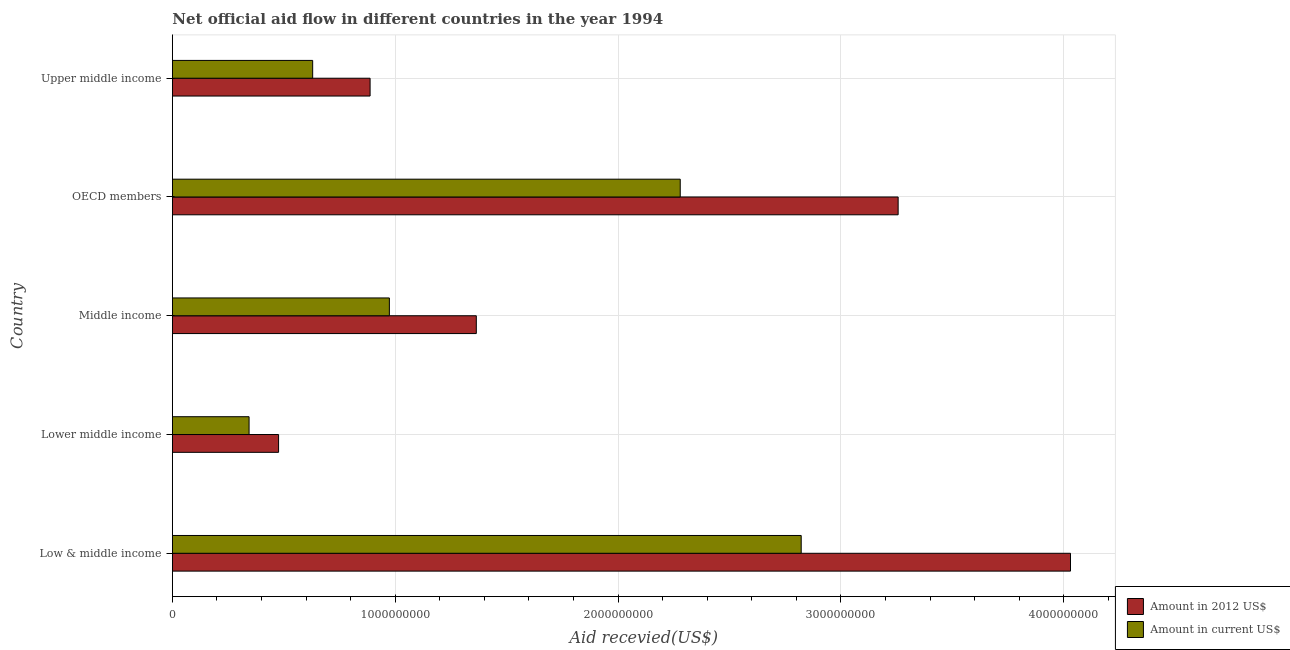How many groups of bars are there?
Your answer should be very brief. 5. Are the number of bars on each tick of the Y-axis equal?
Provide a short and direct response. Yes. What is the label of the 5th group of bars from the top?
Your answer should be very brief. Low & middle income. What is the amount of aid received(expressed in 2012 us$) in Lower middle income?
Make the answer very short. 4.77e+08. Across all countries, what is the maximum amount of aid received(expressed in us$)?
Give a very brief answer. 2.82e+09. Across all countries, what is the minimum amount of aid received(expressed in us$)?
Your response must be concise. 3.44e+08. In which country was the amount of aid received(expressed in 2012 us$) minimum?
Your answer should be compact. Lower middle income. What is the total amount of aid received(expressed in us$) in the graph?
Your answer should be very brief. 7.05e+09. What is the difference between the amount of aid received(expressed in 2012 us$) in Middle income and that in Upper middle income?
Ensure brevity in your answer.  4.77e+08. What is the difference between the amount of aid received(expressed in us$) in Low & middle income and the amount of aid received(expressed in 2012 us$) in OECD members?
Make the answer very short. -4.35e+08. What is the average amount of aid received(expressed in us$) per country?
Provide a succinct answer. 1.41e+09. What is the difference between the amount of aid received(expressed in us$) and amount of aid received(expressed in 2012 us$) in OECD members?
Provide a short and direct response. -9.78e+08. In how many countries, is the amount of aid received(expressed in us$) greater than 2600000000 US$?
Offer a terse response. 1. What is the ratio of the amount of aid received(expressed in us$) in Low & middle income to that in Upper middle income?
Offer a terse response. 4.48. Is the amount of aid received(expressed in 2012 us$) in Low & middle income less than that in Middle income?
Provide a succinct answer. No. Is the difference between the amount of aid received(expressed in 2012 us$) in Lower middle income and Upper middle income greater than the difference between the amount of aid received(expressed in us$) in Lower middle income and Upper middle income?
Your answer should be compact. No. What is the difference between the highest and the second highest amount of aid received(expressed in 2012 us$)?
Give a very brief answer. 7.73e+08. What is the difference between the highest and the lowest amount of aid received(expressed in us$)?
Provide a succinct answer. 2.48e+09. In how many countries, is the amount of aid received(expressed in 2012 us$) greater than the average amount of aid received(expressed in 2012 us$) taken over all countries?
Provide a short and direct response. 2. What does the 1st bar from the top in Low & middle income represents?
Your answer should be very brief. Amount in current US$. What does the 2nd bar from the bottom in Upper middle income represents?
Your answer should be very brief. Amount in current US$. How many bars are there?
Make the answer very short. 10. How many countries are there in the graph?
Your answer should be very brief. 5. Are the values on the major ticks of X-axis written in scientific E-notation?
Offer a terse response. No. Does the graph contain any zero values?
Offer a very short reply. No. Where does the legend appear in the graph?
Your answer should be compact. Bottom right. How many legend labels are there?
Keep it short and to the point. 2. What is the title of the graph?
Give a very brief answer. Net official aid flow in different countries in the year 1994. Does "Females" appear as one of the legend labels in the graph?
Your answer should be very brief. No. What is the label or title of the X-axis?
Your answer should be compact. Aid recevied(US$). What is the Aid recevied(US$) of Amount in 2012 US$ in Low & middle income?
Your answer should be very brief. 4.03e+09. What is the Aid recevied(US$) of Amount in current US$ in Low & middle income?
Your answer should be very brief. 2.82e+09. What is the Aid recevied(US$) in Amount in 2012 US$ in Lower middle income?
Offer a very short reply. 4.77e+08. What is the Aid recevied(US$) in Amount in current US$ in Lower middle income?
Keep it short and to the point. 3.44e+08. What is the Aid recevied(US$) in Amount in 2012 US$ in Middle income?
Ensure brevity in your answer.  1.36e+09. What is the Aid recevied(US$) of Amount in current US$ in Middle income?
Give a very brief answer. 9.74e+08. What is the Aid recevied(US$) in Amount in 2012 US$ in OECD members?
Your answer should be compact. 3.26e+09. What is the Aid recevied(US$) of Amount in current US$ in OECD members?
Ensure brevity in your answer.  2.28e+09. What is the Aid recevied(US$) of Amount in 2012 US$ in Upper middle income?
Your answer should be very brief. 8.87e+08. What is the Aid recevied(US$) of Amount in current US$ in Upper middle income?
Ensure brevity in your answer.  6.30e+08. Across all countries, what is the maximum Aid recevied(US$) of Amount in 2012 US$?
Offer a very short reply. 4.03e+09. Across all countries, what is the maximum Aid recevied(US$) in Amount in current US$?
Offer a terse response. 2.82e+09. Across all countries, what is the minimum Aid recevied(US$) of Amount in 2012 US$?
Offer a very short reply. 4.77e+08. Across all countries, what is the minimum Aid recevied(US$) of Amount in current US$?
Ensure brevity in your answer.  3.44e+08. What is the total Aid recevied(US$) in Amount in 2012 US$ in the graph?
Provide a short and direct response. 1.00e+1. What is the total Aid recevied(US$) in Amount in current US$ in the graph?
Keep it short and to the point. 7.05e+09. What is the difference between the Aid recevied(US$) of Amount in 2012 US$ in Low & middle income and that in Lower middle income?
Your response must be concise. 3.55e+09. What is the difference between the Aid recevied(US$) in Amount in current US$ in Low & middle income and that in Lower middle income?
Give a very brief answer. 2.48e+09. What is the difference between the Aid recevied(US$) in Amount in 2012 US$ in Low & middle income and that in Middle income?
Provide a succinct answer. 2.67e+09. What is the difference between the Aid recevied(US$) in Amount in current US$ in Low & middle income and that in Middle income?
Offer a very short reply. 1.85e+09. What is the difference between the Aid recevied(US$) in Amount in 2012 US$ in Low & middle income and that in OECD members?
Your answer should be very brief. 7.73e+08. What is the difference between the Aid recevied(US$) in Amount in current US$ in Low & middle income and that in OECD members?
Provide a short and direct response. 5.43e+08. What is the difference between the Aid recevied(US$) of Amount in 2012 US$ in Low & middle income and that in Upper middle income?
Give a very brief answer. 3.14e+09. What is the difference between the Aid recevied(US$) in Amount in current US$ in Low & middle income and that in Upper middle income?
Give a very brief answer. 2.19e+09. What is the difference between the Aid recevied(US$) of Amount in 2012 US$ in Lower middle income and that in Middle income?
Your answer should be compact. -8.87e+08. What is the difference between the Aid recevied(US$) of Amount in current US$ in Lower middle income and that in Middle income?
Offer a very short reply. -6.30e+08. What is the difference between the Aid recevied(US$) of Amount in 2012 US$ in Lower middle income and that in OECD members?
Your answer should be very brief. -2.78e+09. What is the difference between the Aid recevied(US$) of Amount in current US$ in Lower middle income and that in OECD members?
Keep it short and to the point. -1.93e+09. What is the difference between the Aid recevied(US$) in Amount in 2012 US$ in Lower middle income and that in Upper middle income?
Make the answer very short. -4.11e+08. What is the difference between the Aid recevied(US$) of Amount in current US$ in Lower middle income and that in Upper middle income?
Your answer should be compact. -2.85e+08. What is the difference between the Aid recevied(US$) in Amount in 2012 US$ in Middle income and that in OECD members?
Offer a terse response. -1.89e+09. What is the difference between the Aid recevied(US$) in Amount in current US$ in Middle income and that in OECD members?
Your response must be concise. -1.31e+09. What is the difference between the Aid recevied(US$) of Amount in 2012 US$ in Middle income and that in Upper middle income?
Make the answer very short. 4.77e+08. What is the difference between the Aid recevied(US$) in Amount in current US$ in Middle income and that in Upper middle income?
Provide a short and direct response. 3.44e+08. What is the difference between the Aid recevied(US$) of Amount in 2012 US$ in OECD members and that in Upper middle income?
Offer a terse response. 2.37e+09. What is the difference between the Aid recevied(US$) in Amount in current US$ in OECD members and that in Upper middle income?
Give a very brief answer. 1.65e+09. What is the difference between the Aid recevied(US$) in Amount in 2012 US$ in Low & middle income and the Aid recevied(US$) in Amount in current US$ in Lower middle income?
Provide a short and direct response. 3.69e+09. What is the difference between the Aid recevied(US$) in Amount in 2012 US$ in Low & middle income and the Aid recevied(US$) in Amount in current US$ in Middle income?
Your answer should be compact. 3.06e+09. What is the difference between the Aid recevied(US$) of Amount in 2012 US$ in Low & middle income and the Aid recevied(US$) of Amount in current US$ in OECD members?
Your response must be concise. 1.75e+09. What is the difference between the Aid recevied(US$) of Amount in 2012 US$ in Low & middle income and the Aid recevied(US$) of Amount in current US$ in Upper middle income?
Your answer should be compact. 3.40e+09. What is the difference between the Aid recevied(US$) of Amount in 2012 US$ in Lower middle income and the Aid recevied(US$) of Amount in current US$ in Middle income?
Give a very brief answer. -4.97e+08. What is the difference between the Aid recevied(US$) of Amount in 2012 US$ in Lower middle income and the Aid recevied(US$) of Amount in current US$ in OECD members?
Your response must be concise. -1.80e+09. What is the difference between the Aid recevied(US$) of Amount in 2012 US$ in Lower middle income and the Aid recevied(US$) of Amount in current US$ in Upper middle income?
Your answer should be compact. -1.53e+08. What is the difference between the Aid recevied(US$) of Amount in 2012 US$ in Middle income and the Aid recevied(US$) of Amount in current US$ in OECD members?
Make the answer very short. -9.15e+08. What is the difference between the Aid recevied(US$) in Amount in 2012 US$ in Middle income and the Aid recevied(US$) in Amount in current US$ in Upper middle income?
Your answer should be compact. 7.34e+08. What is the difference between the Aid recevied(US$) in Amount in 2012 US$ in OECD members and the Aid recevied(US$) in Amount in current US$ in Upper middle income?
Provide a succinct answer. 2.63e+09. What is the average Aid recevied(US$) in Amount in 2012 US$ per country?
Provide a short and direct response. 2.00e+09. What is the average Aid recevied(US$) in Amount in current US$ per country?
Your answer should be very brief. 1.41e+09. What is the difference between the Aid recevied(US$) in Amount in 2012 US$ and Aid recevied(US$) in Amount in current US$ in Low & middle income?
Your answer should be very brief. 1.21e+09. What is the difference between the Aid recevied(US$) of Amount in 2012 US$ and Aid recevied(US$) of Amount in current US$ in Lower middle income?
Your answer should be compact. 1.32e+08. What is the difference between the Aid recevied(US$) of Amount in 2012 US$ and Aid recevied(US$) of Amount in current US$ in Middle income?
Your answer should be very brief. 3.90e+08. What is the difference between the Aid recevied(US$) of Amount in 2012 US$ and Aid recevied(US$) of Amount in current US$ in OECD members?
Your response must be concise. 9.78e+08. What is the difference between the Aid recevied(US$) of Amount in 2012 US$ and Aid recevied(US$) of Amount in current US$ in Upper middle income?
Provide a succinct answer. 2.58e+08. What is the ratio of the Aid recevied(US$) in Amount in 2012 US$ in Low & middle income to that in Lower middle income?
Give a very brief answer. 8.46. What is the ratio of the Aid recevied(US$) of Amount in current US$ in Low & middle income to that in Lower middle income?
Your answer should be compact. 8.2. What is the ratio of the Aid recevied(US$) in Amount in 2012 US$ in Low & middle income to that in Middle income?
Your answer should be very brief. 2.96. What is the ratio of the Aid recevied(US$) in Amount in current US$ in Low & middle income to that in Middle income?
Provide a short and direct response. 2.9. What is the ratio of the Aid recevied(US$) of Amount in 2012 US$ in Low & middle income to that in OECD members?
Your answer should be very brief. 1.24. What is the ratio of the Aid recevied(US$) in Amount in current US$ in Low & middle income to that in OECD members?
Offer a very short reply. 1.24. What is the ratio of the Aid recevied(US$) in Amount in 2012 US$ in Low & middle income to that in Upper middle income?
Offer a very short reply. 4.54. What is the ratio of the Aid recevied(US$) of Amount in current US$ in Low & middle income to that in Upper middle income?
Make the answer very short. 4.48. What is the ratio of the Aid recevied(US$) of Amount in 2012 US$ in Lower middle income to that in Middle income?
Provide a succinct answer. 0.35. What is the ratio of the Aid recevied(US$) in Amount in current US$ in Lower middle income to that in Middle income?
Your answer should be compact. 0.35. What is the ratio of the Aid recevied(US$) of Amount in 2012 US$ in Lower middle income to that in OECD members?
Keep it short and to the point. 0.15. What is the ratio of the Aid recevied(US$) of Amount in current US$ in Lower middle income to that in OECD members?
Your response must be concise. 0.15. What is the ratio of the Aid recevied(US$) of Amount in 2012 US$ in Lower middle income to that in Upper middle income?
Give a very brief answer. 0.54. What is the ratio of the Aid recevied(US$) of Amount in current US$ in Lower middle income to that in Upper middle income?
Your answer should be compact. 0.55. What is the ratio of the Aid recevied(US$) in Amount in 2012 US$ in Middle income to that in OECD members?
Ensure brevity in your answer.  0.42. What is the ratio of the Aid recevied(US$) in Amount in current US$ in Middle income to that in OECD members?
Provide a succinct answer. 0.43. What is the ratio of the Aid recevied(US$) in Amount in 2012 US$ in Middle income to that in Upper middle income?
Provide a short and direct response. 1.54. What is the ratio of the Aid recevied(US$) in Amount in current US$ in Middle income to that in Upper middle income?
Your answer should be compact. 1.55. What is the ratio of the Aid recevied(US$) in Amount in 2012 US$ in OECD members to that in Upper middle income?
Ensure brevity in your answer.  3.67. What is the ratio of the Aid recevied(US$) in Amount in current US$ in OECD members to that in Upper middle income?
Keep it short and to the point. 3.62. What is the difference between the highest and the second highest Aid recevied(US$) in Amount in 2012 US$?
Provide a succinct answer. 7.73e+08. What is the difference between the highest and the second highest Aid recevied(US$) in Amount in current US$?
Ensure brevity in your answer.  5.43e+08. What is the difference between the highest and the lowest Aid recevied(US$) of Amount in 2012 US$?
Provide a short and direct response. 3.55e+09. What is the difference between the highest and the lowest Aid recevied(US$) in Amount in current US$?
Give a very brief answer. 2.48e+09. 